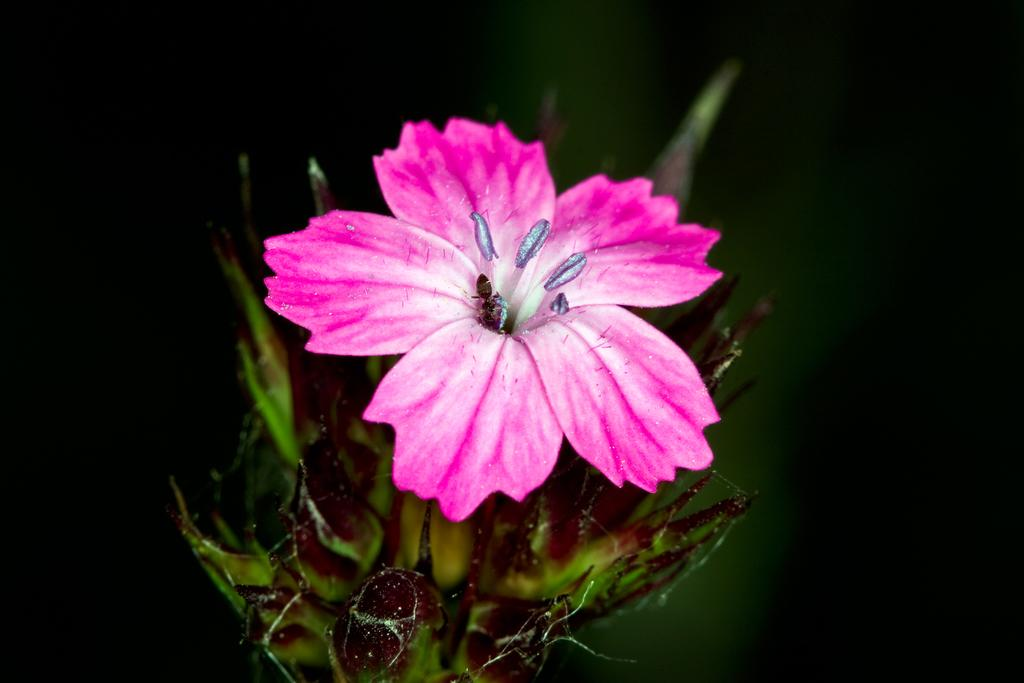What type of creature can be seen in the image? There is an ant in the image. Are there any other creatures like the ant in the image? Yes, there are insects in the image. What are the insects doing in the image? The insects are on a pink color flower. What else can be seen in the image besides the insects? There are other objects visible in the image. Can you tell me when the ant was born in the image? The image does not provide information about the ant's birth, so we cannot determine when it was born. Is there a rat visible in the image? No, there is no rat present in the image. 